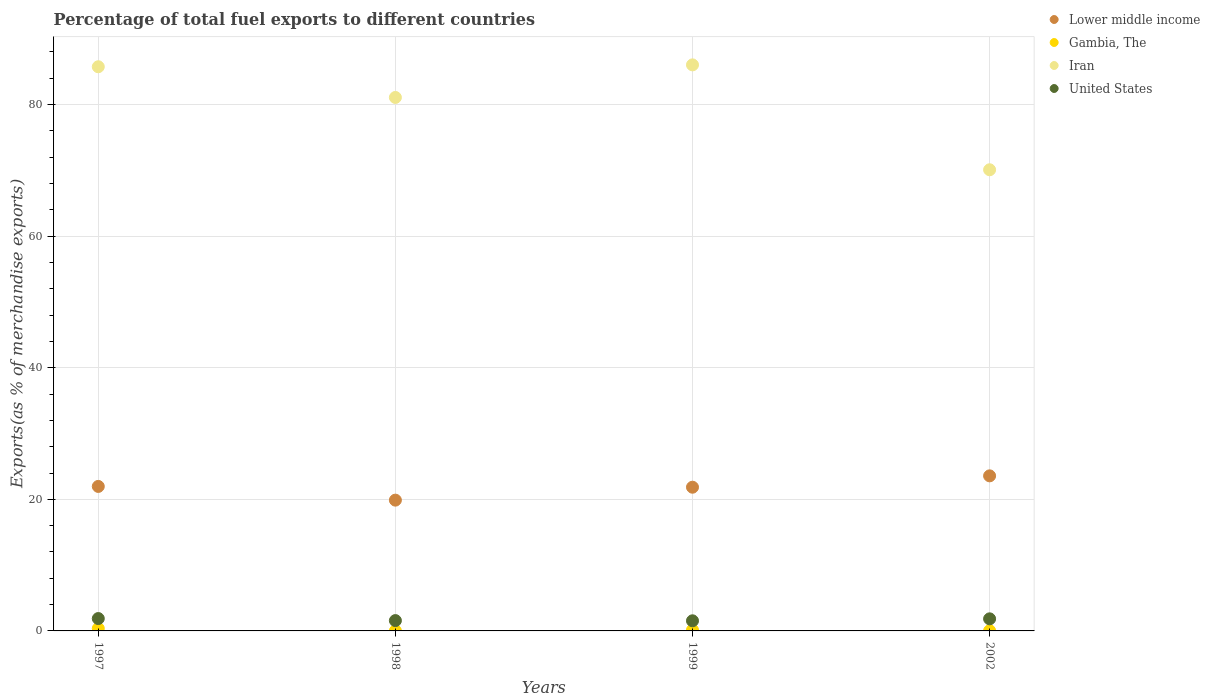Is the number of dotlines equal to the number of legend labels?
Give a very brief answer. Yes. What is the percentage of exports to different countries in Lower middle income in 2002?
Offer a terse response. 23.57. Across all years, what is the maximum percentage of exports to different countries in Lower middle income?
Keep it short and to the point. 23.57. Across all years, what is the minimum percentage of exports to different countries in Gambia, The?
Offer a very short reply. 0.02. What is the total percentage of exports to different countries in Gambia, The in the graph?
Your answer should be very brief. 0.55. What is the difference between the percentage of exports to different countries in Lower middle income in 1999 and that in 2002?
Your response must be concise. -1.73. What is the difference between the percentage of exports to different countries in Lower middle income in 2002 and the percentage of exports to different countries in United States in 1997?
Give a very brief answer. 21.69. What is the average percentage of exports to different countries in Iran per year?
Your answer should be very brief. 80.74. In the year 1999, what is the difference between the percentage of exports to different countries in United States and percentage of exports to different countries in Gambia, The?
Offer a very short reply. 1.41. In how many years, is the percentage of exports to different countries in Lower middle income greater than 76 %?
Keep it short and to the point. 0. What is the ratio of the percentage of exports to different countries in Iran in 1997 to that in 2002?
Keep it short and to the point. 1.22. Is the percentage of exports to different countries in Iran in 1997 less than that in 1998?
Ensure brevity in your answer.  No. What is the difference between the highest and the second highest percentage of exports to different countries in Iran?
Your response must be concise. 0.29. What is the difference between the highest and the lowest percentage of exports to different countries in United States?
Make the answer very short. 0.34. In how many years, is the percentage of exports to different countries in Iran greater than the average percentage of exports to different countries in Iran taken over all years?
Ensure brevity in your answer.  3. Is it the case that in every year, the sum of the percentage of exports to different countries in Iran and percentage of exports to different countries in United States  is greater than the sum of percentage of exports to different countries in Lower middle income and percentage of exports to different countries in Gambia, The?
Provide a short and direct response. Yes. Is it the case that in every year, the sum of the percentage of exports to different countries in Iran and percentage of exports to different countries in United States  is greater than the percentage of exports to different countries in Gambia, The?
Keep it short and to the point. Yes. How many years are there in the graph?
Your answer should be compact. 4. What is the difference between two consecutive major ticks on the Y-axis?
Make the answer very short. 20. Does the graph contain any zero values?
Offer a terse response. No. Does the graph contain grids?
Give a very brief answer. Yes. Where does the legend appear in the graph?
Make the answer very short. Top right. How many legend labels are there?
Provide a succinct answer. 4. What is the title of the graph?
Give a very brief answer. Percentage of total fuel exports to different countries. What is the label or title of the Y-axis?
Make the answer very short. Exports(as % of merchandise exports). What is the Exports(as % of merchandise exports) of Lower middle income in 1997?
Provide a short and direct response. 21.96. What is the Exports(as % of merchandise exports) in Gambia, The in 1997?
Offer a terse response. 0.37. What is the Exports(as % of merchandise exports) of Iran in 1997?
Provide a succinct answer. 85.75. What is the Exports(as % of merchandise exports) of United States in 1997?
Offer a terse response. 1.88. What is the Exports(as % of merchandise exports) in Lower middle income in 1998?
Keep it short and to the point. 19.88. What is the Exports(as % of merchandise exports) in Gambia, The in 1998?
Give a very brief answer. 0.02. What is the Exports(as % of merchandise exports) in Iran in 1998?
Keep it short and to the point. 81.08. What is the Exports(as % of merchandise exports) of United States in 1998?
Offer a terse response. 1.57. What is the Exports(as % of merchandise exports) of Lower middle income in 1999?
Your answer should be very brief. 21.84. What is the Exports(as % of merchandise exports) of Gambia, The in 1999?
Offer a very short reply. 0.13. What is the Exports(as % of merchandise exports) of Iran in 1999?
Keep it short and to the point. 86.04. What is the Exports(as % of merchandise exports) in United States in 1999?
Make the answer very short. 1.54. What is the Exports(as % of merchandise exports) of Lower middle income in 2002?
Your response must be concise. 23.57. What is the Exports(as % of merchandise exports) of Gambia, The in 2002?
Make the answer very short. 0.03. What is the Exports(as % of merchandise exports) of Iran in 2002?
Keep it short and to the point. 70.09. What is the Exports(as % of merchandise exports) in United States in 2002?
Ensure brevity in your answer.  1.84. Across all years, what is the maximum Exports(as % of merchandise exports) in Lower middle income?
Your response must be concise. 23.57. Across all years, what is the maximum Exports(as % of merchandise exports) of Gambia, The?
Ensure brevity in your answer.  0.37. Across all years, what is the maximum Exports(as % of merchandise exports) of Iran?
Your answer should be compact. 86.04. Across all years, what is the maximum Exports(as % of merchandise exports) in United States?
Offer a very short reply. 1.88. Across all years, what is the minimum Exports(as % of merchandise exports) of Lower middle income?
Make the answer very short. 19.88. Across all years, what is the minimum Exports(as % of merchandise exports) in Gambia, The?
Your answer should be compact. 0.02. Across all years, what is the minimum Exports(as % of merchandise exports) of Iran?
Your answer should be compact. 70.09. Across all years, what is the minimum Exports(as % of merchandise exports) of United States?
Keep it short and to the point. 1.54. What is the total Exports(as % of merchandise exports) in Lower middle income in the graph?
Keep it short and to the point. 87.25. What is the total Exports(as % of merchandise exports) in Gambia, The in the graph?
Give a very brief answer. 0.55. What is the total Exports(as % of merchandise exports) of Iran in the graph?
Make the answer very short. 322.96. What is the total Exports(as % of merchandise exports) in United States in the graph?
Offer a very short reply. 6.83. What is the difference between the Exports(as % of merchandise exports) of Lower middle income in 1997 and that in 1998?
Your answer should be very brief. 2.08. What is the difference between the Exports(as % of merchandise exports) in Gambia, The in 1997 and that in 1998?
Give a very brief answer. 0.35. What is the difference between the Exports(as % of merchandise exports) in Iran in 1997 and that in 1998?
Your answer should be very brief. 4.67. What is the difference between the Exports(as % of merchandise exports) in United States in 1997 and that in 1998?
Provide a succinct answer. 0.31. What is the difference between the Exports(as % of merchandise exports) in Lower middle income in 1997 and that in 1999?
Keep it short and to the point. 0.12. What is the difference between the Exports(as % of merchandise exports) of Gambia, The in 1997 and that in 1999?
Your response must be concise. 0.23. What is the difference between the Exports(as % of merchandise exports) in Iran in 1997 and that in 1999?
Offer a terse response. -0.29. What is the difference between the Exports(as % of merchandise exports) in United States in 1997 and that in 1999?
Your answer should be very brief. 0.34. What is the difference between the Exports(as % of merchandise exports) of Lower middle income in 1997 and that in 2002?
Your response must be concise. -1.61. What is the difference between the Exports(as % of merchandise exports) in Gambia, The in 1997 and that in 2002?
Offer a very short reply. 0.34. What is the difference between the Exports(as % of merchandise exports) in Iran in 1997 and that in 2002?
Your answer should be very brief. 15.66. What is the difference between the Exports(as % of merchandise exports) in United States in 1997 and that in 2002?
Offer a terse response. 0.04. What is the difference between the Exports(as % of merchandise exports) in Lower middle income in 1998 and that in 1999?
Your response must be concise. -1.97. What is the difference between the Exports(as % of merchandise exports) of Gambia, The in 1998 and that in 1999?
Your answer should be very brief. -0.12. What is the difference between the Exports(as % of merchandise exports) in Iran in 1998 and that in 1999?
Ensure brevity in your answer.  -4.95. What is the difference between the Exports(as % of merchandise exports) of United States in 1998 and that in 1999?
Offer a very short reply. 0.03. What is the difference between the Exports(as % of merchandise exports) of Lower middle income in 1998 and that in 2002?
Give a very brief answer. -3.69. What is the difference between the Exports(as % of merchandise exports) of Gambia, The in 1998 and that in 2002?
Make the answer very short. -0.01. What is the difference between the Exports(as % of merchandise exports) in Iran in 1998 and that in 2002?
Provide a short and direct response. 10.99. What is the difference between the Exports(as % of merchandise exports) of United States in 1998 and that in 2002?
Keep it short and to the point. -0.27. What is the difference between the Exports(as % of merchandise exports) of Lower middle income in 1999 and that in 2002?
Keep it short and to the point. -1.73. What is the difference between the Exports(as % of merchandise exports) of Gambia, The in 1999 and that in 2002?
Make the answer very short. 0.1. What is the difference between the Exports(as % of merchandise exports) in Iran in 1999 and that in 2002?
Offer a terse response. 15.94. What is the difference between the Exports(as % of merchandise exports) of United States in 1999 and that in 2002?
Your answer should be compact. -0.3. What is the difference between the Exports(as % of merchandise exports) of Lower middle income in 1997 and the Exports(as % of merchandise exports) of Gambia, The in 1998?
Ensure brevity in your answer.  21.94. What is the difference between the Exports(as % of merchandise exports) in Lower middle income in 1997 and the Exports(as % of merchandise exports) in Iran in 1998?
Provide a short and direct response. -59.12. What is the difference between the Exports(as % of merchandise exports) in Lower middle income in 1997 and the Exports(as % of merchandise exports) in United States in 1998?
Give a very brief answer. 20.39. What is the difference between the Exports(as % of merchandise exports) of Gambia, The in 1997 and the Exports(as % of merchandise exports) of Iran in 1998?
Give a very brief answer. -80.72. What is the difference between the Exports(as % of merchandise exports) of Gambia, The in 1997 and the Exports(as % of merchandise exports) of United States in 1998?
Ensure brevity in your answer.  -1.2. What is the difference between the Exports(as % of merchandise exports) in Iran in 1997 and the Exports(as % of merchandise exports) in United States in 1998?
Provide a succinct answer. 84.18. What is the difference between the Exports(as % of merchandise exports) of Lower middle income in 1997 and the Exports(as % of merchandise exports) of Gambia, The in 1999?
Your answer should be very brief. 21.83. What is the difference between the Exports(as % of merchandise exports) of Lower middle income in 1997 and the Exports(as % of merchandise exports) of Iran in 1999?
Make the answer very short. -64.07. What is the difference between the Exports(as % of merchandise exports) of Lower middle income in 1997 and the Exports(as % of merchandise exports) of United States in 1999?
Give a very brief answer. 20.42. What is the difference between the Exports(as % of merchandise exports) in Gambia, The in 1997 and the Exports(as % of merchandise exports) in Iran in 1999?
Offer a terse response. -85.67. What is the difference between the Exports(as % of merchandise exports) of Gambia, The in 1997 and the Exports(as % of merchandise exports) of United States in 1999?
Give a very brief answer. -1.17. What is the difference between the Exports(as % of merchandise exports) in Iran in 1997 and the Exports(as % of merchandise exports) in United States in 1999?
Ensure brevity in your answer.  84.21. What is the difference between the Exports(as % of merchandise exports) of Lower middle income in 1997 and the Exports(as % of merchandise exports) of Gambia, The in 2002?
Give a very brief answer. 21.93. What is the difference between the Exports(as % of merchandise exports) of Lower middle income in 1997 and the Exports(as % of merchandise exports) of Iran in 2002?
Keep it short and to the point. -48.13. What is the difference between the Exports(as % of merchandise exports) of Lower middle income in 1997 and the Exports(as % of merchandise exports) of United States in 2002?
Ensure brevity in your answer.  20.12. What is the difference between the Exports(as % of merchandise exports) of Gambia, The in 1997 and the Exports(as % of merchandise exports) of Iran in 2002?
Ensure brevity in your answer.  -69.72. What is the difference between the Exports(as % of merchandise exports) in Gambia, The in 1997 and the Exports(as % of merchandise exports) in United States in 2002?
Offer a very short reply. -1.47. What is the difference between the Exports(as % of merchandise exports) of Iran in 1997 and the Exports(as % of merchandise exports) of United States in 2002?
Your response must be concise. 83.91. What is the difference between the Exports(as % of merchandise exports) of Lower middle income in 1998 and the Exports(as % of merchandise exports) of Gambia, The in 1999?
Make the answer very short. 19.74. What is the difference between the Exports(as % of merchandise exports) in Lower middle income in 1998 and the Exports(as % of merchandise exports) in Iran in 1999?
Offer a terse response. -66.16. What is the difference between the Exports(as % of merchandise exports) in Lower middle income in 1998 and the Exports(as % of merchandise exports) in United States in 1999?
Keep it short and to the point. 18.34. What is the difference between the Exports(as % of merchandise exports) of Gambia, The in 1998 and the Exports(as % of merchandise exports) of Iran in 1999?
Make the answer very short. -86.02. What is the difference between the Exports(as % of merchandise exports) in Gambia, The in 1998 and the Exports(as % of merchandise exports) in United States in 1999?
Ensure brevity in your answer.  -1.52. What is the difference between the Exports(as % of merchandise exports) of Iran in 1998 and the Exports(as % of merchandise exports) of United States in 1999?
Provide a short and direct response. 79.54. What is the difference between the Exports(as % of merchandise exports) in Lower middle income in 1998 and the Exports(as % of merchandise exports) in Gambia, The in 2002?
Offer a terse response. 19.85. What is the difference between the Exports(as % of merchandise exports) in Lower middle income in 1998 and the Exports(as % of merchandise exports) in Iran in 2002?
Give a very brief answer. -50.21. What is the difference between the Exports(as % of merchandise exports) in Lower middle income in 1998 and the Exports(as % of merchandise exports) in United States in 2002?
Your answer should be very brief. 18.04. What is the difference between the Exports(as % of merchandise exports) in Gambia, The in 1998 and the Exports(as % of merchandise exports) in Iran in 2002?
Your answer should be very brief. -70.07. What is the difference between the Exports(as % of merchandise exports) in Gambia, The in 1998 and the Exports(as % of merchandise exports) in United States in 2002?
Ensure brevity in your answer.  -1.82. What is the difference between the Exports(as % of merchandise exports) of Iran in 1998 and the Exports(as % of merchandise exports) of United States in 2002?
Your answer should be compact. 79.24. What is the difference between the Exports(as % of merchandise exports) of Lower middle income in 1999 and the Exports(as % of merchandise exports) of Gambia, The in 2002?
Offer a terse response. 21.81. What is the difference between the Exports(as % of merchandise exports) in Lower middle income in 1999 and the Exports(as % of merchandise exports) in Iran in 2002?
Your answer should be compact. -48.25. What is the difference between the Exports(as % of merchandise exports) of Lower middle income in 1999 and the Exports(as % of merchandise exports) of United States in 2002?
Offer a terse response. 20.01. What is the difference between the Exports(as % of merchandise exports) of Gambia, The in 1999 and the Exports(as % of merchandise exports) of Iran in 2002?
Provide a succinct answer. -69.96. What is the difference between the Exports(as % of merchandise exports) of Gambia, The in 1999 and the Exports(as % of merchandise exports) of United States in 2002?
Ensure brevity in your answer.  -1.7. What is the difference between the Exports(as % of merchandise exports) in Iran in 1999 and the Exports(as % of merchandise exports) in United States in 2002?
Your answer should be compact. 84.2. What is the average Exports(as % of merchandise exports) of Lower middle income per year?
Make the answer very short. 21.81. What is the average Exports(as % of merchandise exports) in Gambia, The per year?
Keep it short and to the point. 0.14. What is the average Exports(as % of merchandise exports) in Iran per year?
Ensure brevity in your answer.  80.74. What is the average Exports(as % of merchandise exports) of United States per year?
Ensure brevity in your answer.  1.71. In the year 1997, what is the difference between the Exports(as % of merchandise exports) of Lower middle income and Exports(as % of merchandise exports) of Gambia, The?
Provide a succinct answer. 21.59. In the year 1997, what is the difference between the Exports(as % of merchandise exports) of Lower middle income and Exports(as % of merchandise exports) of Iran?
Your response must be concise. -63.79. In the year 1997, what is the difference between the Exports(as % of merchandise exports) of Lower middle income and Exports(as % of merchandise exports) of United States?
Offer a terse response. 20.08. In the year 1997, what is the difference between the Exports(as % of merchandise exports) of Gambia, The and Exports(as % of merchandise exports) of Iran?
Your answer should be compact. -85.38. In the year 1997, what is the difference between the Exports(as % of merchandise exports) in Gambia, The and Exports(as % of merchandise exports) in United States?
Give a very brief answer. -1.51. In the year 1997, what is the difference between the Exports(as % of merchandise exports) of Iran and Exports(as % of merchandise exports) of United States?
Your response must be concise. 83.87. In the year 1998, what is the difference between the Exports(as % of merchandise exports) in Lower middle income and Exports(as % of merchandise exports) in Gambia, The?
Your answer should be compact. 19.86. In the year 1998, what is the difference between the Exports(as % of merchandise exports) of Lower middle income and Exports(as % of merchandise exports) of Iran?
Offer a terse response. -61.2. In the year 1998, what is the difference between the Exports(as % of merchandise exports) in Lower middle income and Exports(as % of merchandise exports) in United States?
Your answer should be very brief. 18.31. In the year 1998, what is the difference between the Exports(as % of merchandise exports) in Gambia, The and Exports(as % of merchandise exports) in Iran?
Your response must be concise. -81.06. In the year 1998, what is the difference between the Exports(as % of merchandise exports) of Gambia, The and Exports(as % of merchandise exports) of United States?
Your answer should be very brief. -1.55. In the year 1998, what is the difference between the Exports(as % of merchandise exports) in Iran and Exports(as % of merchandise exports) in United States?
Offer a very short reply. 79.51. In the year 1999, what is the difference between the Exports(as % of merchandise exports) of Lower middle income and Exports(as % of merchandise exports) of Gambia, The?
Your answer should be compact. 21.71. In the year 1999, what is the difference between the Exports(as % of merchandise exports) of Lower middle income and Exports(as % of merchandise exports) of Iran?
Your answer should be compact. -64.19. In the year 1999, what is the difference between the Exports(as % of merchandise exports) in Lower middle income and Exports(as % of merchandise exports) in United States?
Give a very brief answer. 20.3. In the year 1999, what is the difference between the Exports(as % of merchandise exports) in Gambia, The and Exports(as % of merchandise exports) in Iran?
Make the answer very short. -85.9. In the year 1999, what is the difference between the Exports(as % of merchandise exports) of Gambia, The and Exports(as % of merchandise exports) of United States?
Offer a terse response. -1.41. In the year 1999, what is the difference between the Exports(as % of merchandise exports) in Iran and Exports(as % of merchandise exports) in United States?
Your answer should be very brief. 84.5. In the year 2002, what is the difference between the Exports(as % of merchandise exports) in Lower middle income and Exports(as % of merchandise exports) in Gambia, The?
Your response must be concise. 23.54. In the year 2002, what is the difference between the Exports(as % of merchandise exports) in Lower middle income and Exports(as % of merchandise exports) in Iran?
Provide a short and direct response. -46.52. In the year 2002, what is the difference between the Exports(as % of merchandise exports) in Lower middle income and Exports(as % of merchandise exports) in United States?
Provide a succinct answer. 21.73. In the year 2002, what is the difference between the Exports(as % of merchandise exports) in Gambia, The and Exports(as % of merchandise exports) in Iran?
Your response must be concise. -70.06. In the year 2002, what is the difference between the Exports(as % of merchandise exports) of Gambia, The and Exports(as % of merchandise exports) of United States?
Offer a terse response. -1.81. In the year 2002, what is the difference between the Exports(as % of merchandise exports) of Iran and Exports(as % of merchandise exports) of United States?
Make the answer very short. 68.25. What is the ratio of the Exports(as % of merchandise exports) in Lower middle income in 1997 to that in 1998?
Provide a short and direct response. 1.1. What is the ratio of the Exports(as % of merchandise exports) of Gambia, The in 1997 to that in 1998?
Ensure brevity in your answer.  21.12. What is the ratio of the Exports(as % of merchandise exports) in Iran in 1997 to that in 1998?
Your answer should be very brief. 1.06. What is the ratio of the Exports(as % of merchandise exports) of United States in 1997 to that in 1998?
Offer a terse response. 1.2. What is the ratio of the Exports(as % of merchandise exports) of Lower middle income in 1997 to that in 1999?
Your answer should be compact. 1.01. What is the ratio of the Exports(as % of merchandise exports) of Gambia, The in 1997 to that in 1999?
Provide a succinct answer. 2.77. What is the ratio of the Exports(as % of merchandise exports) in United States in 1997 to that in 1999?
Your answer should be very brief. 1.22. What is the ratio of the Exports(as % of merchandise exports) of Lower middle income in 1997 to that in 2002?
Your answer should be compact. 0.93. What is the ratio of the Exports(as % of merchandise exports) of Gambia, The in 1997 to that in 2002?
Provide a short and direct response. 12.07. What is the ratio of the Exports(as % of merchandise exports) in Iran in 1997 to that in 2002?
Your answer should be compact. 1.22. What is the ratio of the Exports(as % of merchandise exports) in United States in 1997 to that in 2002?
Provide a short and direct response. 1.02. What is the ratio of the Exports(as % of merchandise exports) of Lower middle income in 1998 to that in 1999?
Your response must be concise. 0.91. What is the ratio of the Exports(as % of merchandise exports) of Gambia, The in 1998 to that in 1999?
Keep it short and to the point. 0.13. What is the ratio of the Exports(as % of merchandise exports) in Iran in 1998 to that in 1999?
Keep it short and to the point. 0.94. What is the ratio of the Exports(as % of merchandise exports) of United States in 1998 to that in 1999?
Provide a succinct answer. 1.02. What is the ratio of the Exports(as % of merchandise exports) of Lower middle income in 1998 to that in 2002?
Keep it short and to the point. 0.84. What is the ratio of the Exports(as % of merchandise exports) in Gambia, The in 1998 to that in 2002?
Offer a very short reply. 0.57. What is the ratio of the Exports(as % of merchandise exports) in Iran in 1998 to that in 2002?
Keep it short and to the point. 1.16. What is the ratio of the Exports(as % of merchandise exports) of United States in 1998 to that in 2002?
Provide a short and direct response. 0.85. What is the ratio of the Exports(as % of merchandise exports) in Lower middle income in 1999 to that in 2002?
Provide a succinct answer. 0.93. What is the ratio of the Exports(as % of merchandise exports) of Gambia, The in 1999 to that in 2002?
Make the answer very short. 4.36. What is the ratio of the Exports(as % of merchandise exports) of Iran in 1999 to that in 2002?
Make the answer very short. 1.23. What is the ratio of the Exports(as % of merchandise exports) in United States in 1999 to that in 2002?
Ensure brevity in your answer.  0.84. What is the difference between the highest and the second highest Exports(as % of merchandise exports) of Lower middle income?
Provide a short and direct response. 1.61. What is the difference between the highest and the second highest Exports(as % of merchandise exports) of Gambia, The?
Provide a short and direct response. 0.23. What is the difference between the highest and the second highest Exports(as % of merchandise exports) in Iran?
Offer a terse response. 0.29. What is the difference between the highest and the second highest Exports(as % of merchandise exports) of United States?
Offer a terse response. 0.04. What is the difference between the highest and the lowest Exports(as % of merchandise exports) in Lower middle income?
Your response must be concise. 3.69. What is the difference between the highest and the lowest Exports(as % of merchandise exports) in Gambia, The?
Make the answer very short. 0.35. What is the difference between the highest and the lowest Exports(as % of merchandise exports) in Iran?
Your answer should be very brief. 15.94. What is the difference between the highest and the lowest Exports(as % of merchandise exports) of United States?
Ensure brevity in your answer.  0.34. 